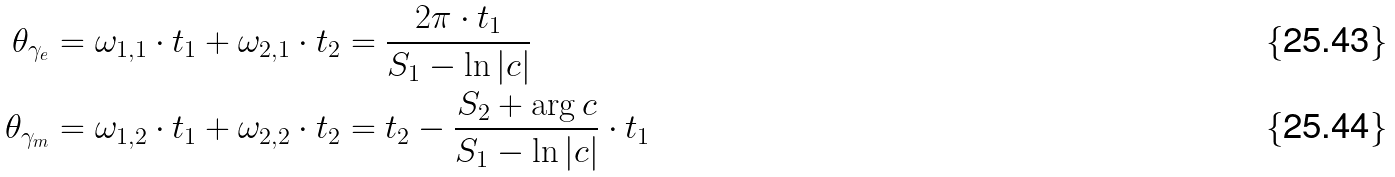Convert formula to latex. <formula><loc_0><loc_0><loc_500><loc_500>\theta _ { \gamma _ { e } } & = \omega _ { 1 , 1 } \cdot t _ { 1 } + \omega _ { 2 , 1 } \cdot t _ { 2 } = \frac { 2 \pi \cdot t _ { 1 } } { S _ { 1 } - \ln | c | } \\ \theta _ { \gamma _ { m } } & = \omega _ { 1 , 2 } \cdot t _ { 1 } + \omega _ { 2 , 2 } \cdot t _ { 2 } = t _ { 2 } - \frac { S _ { 2 } + \arg c } { S _ { 1 } - \ln | c | } \cdot t _ { 1 }</formula> 